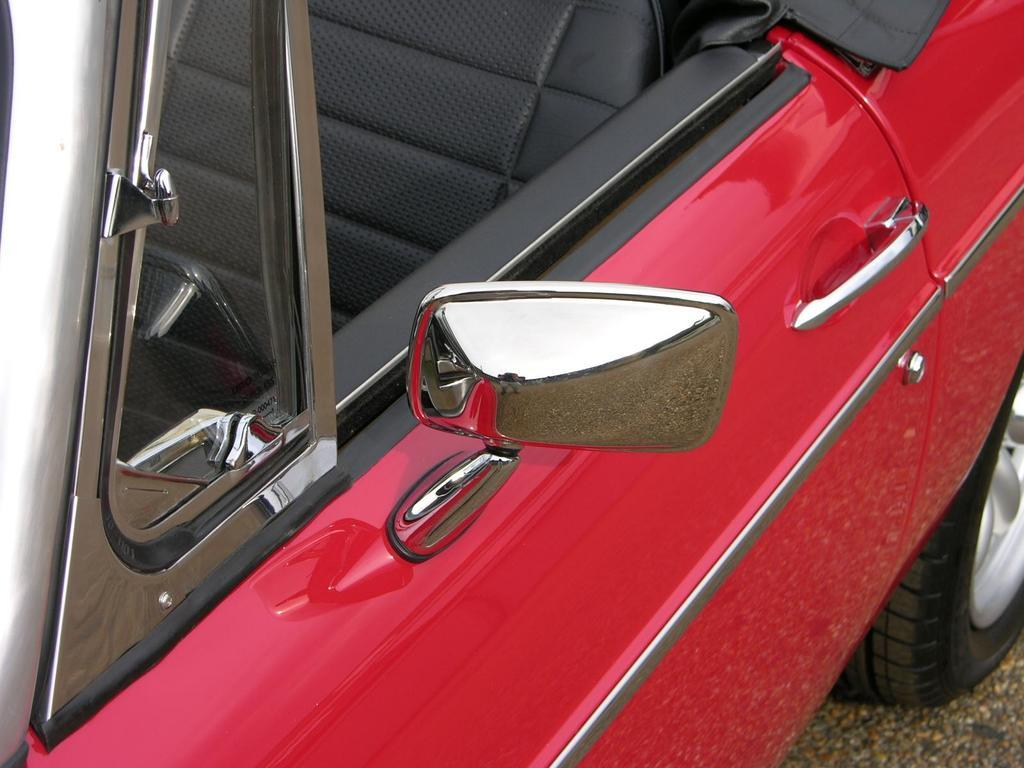What color is the car in the image? The car in the image is red. Can you describe the setting in the image? There is a road at the bottom towards the right side of the image. How does the snail contribute to the traffic jam in the image? There is no snail or traffic jam present in the image. What type of jam is being served with the car in the image? There is no jam present in the image; it features a red car and a road. 